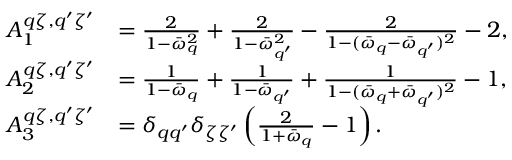<formula> <loc_0><loc_0><loc_500><loc_500>\begin{array} { r l } { A _ { 1 } ^ { q \zeta , q ^ { \prime } \zeta ^ { \prime } } } & { = \frac { 2 } { 1 - \bar { \omega } _ { q } ^ { 2 } } + \frac { 2 } { 1 - \bar { \omega } _ { q ^ { \prime } } ^ { 2 } } - \frac { 2 } { 1 - ( \bar { \omega } _ { q } - \bar { \omega } _ { q ^ { \prime } } ) ^ { 2 } } - 2 , } \\ { A _ { 2 } ^ { q \zeta , q ^ { \prime } \zeta ^ { \prime } } } & { = \frac { 1 } { 1 - \bar { \omega } _ { q } } + \frac { 1 } { 1 - \bar { \omega } _ { q ^ { \prime } } } + \frac { 1 } { 1 - ( \bar { \omega } _ { q } + \bar { \omega } _ { q ^ { \prime } } ) ^ { 2 } } - 1 , } \\ { A _ { 3 } ^ { q \zeta , q ^ { \prime } \zeta ^ { \prime } } } & { = \delta _ { q q ^ { \prime } } \delta _ { \zeta \zeta ^ { \prime } } \left ( \frac { 2 } { 1 + \bar { \omega } _ { q } } - 1 \right ) . } \end{array}</formula> 